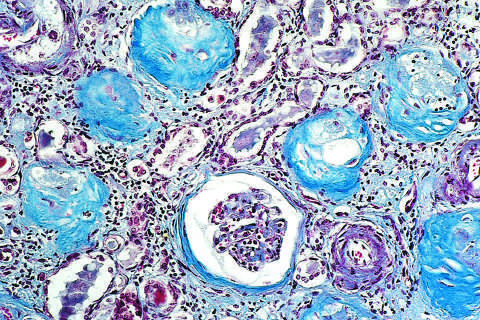does a masson trichrome preparation show complete replacement of virtually all glomeruli by blue-staining collagen?
Answer the question using a single word or phrase. Yes 